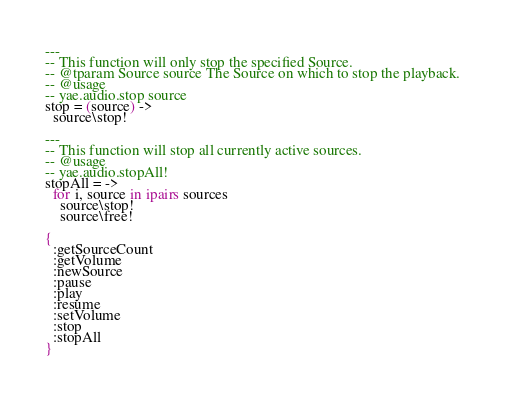<code> <loc_0><loc_0><loc_500><loc_500><_MoonScript_>
---
-- This function will only stop the specified Source.
-- @tparam Source source The Source on which to stop the playback.
-- @usage
-- yae.audio.stop source
stop = (source) ->
  source\stop!

---
-- This function will stop all currently active sources.
-- @usage
-- yae.audio.stopAll!
stopAll = ->
  for i, source in ipairs sources
    source\stop!
    source\free!

{
  :getSourceCount
  :getVolume
  :newSource
  :pause
  :play
  :resume
  :setVolume
  :stop
  :stopAll
}
</code> 